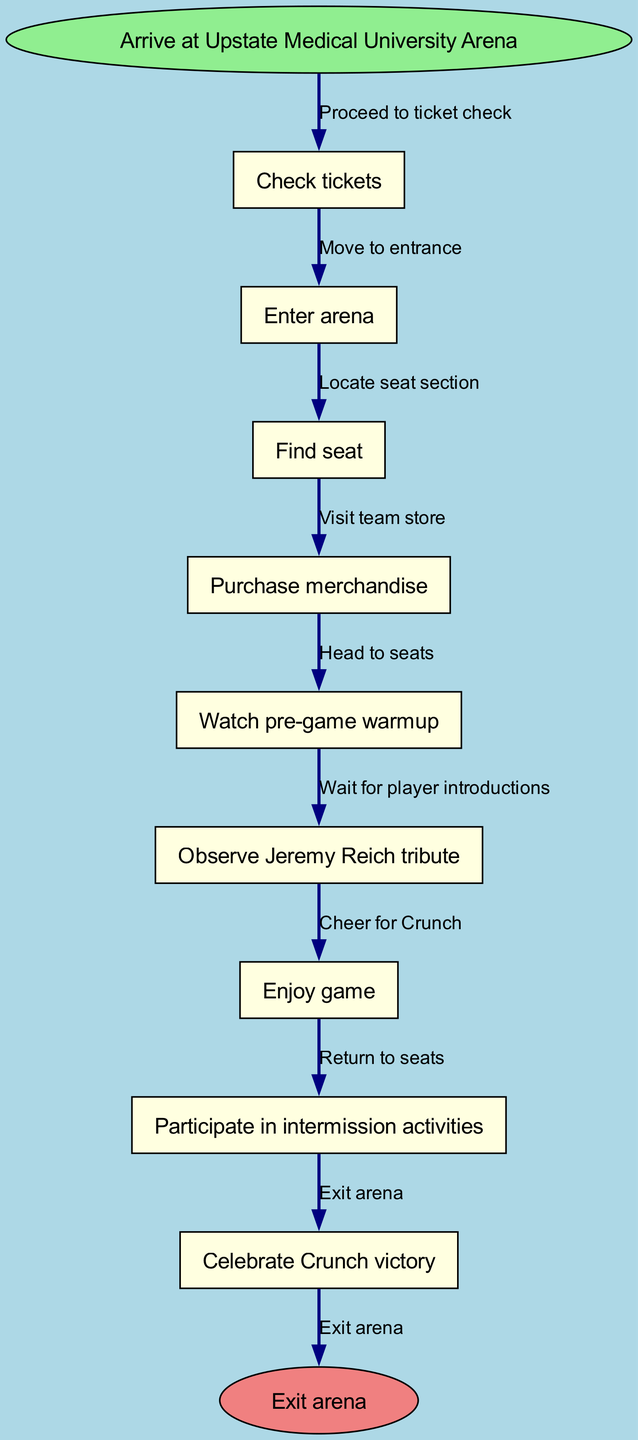What is the first action upon arriving at the arena? The flow chart starts with the first node being "Arrive at Upstate Medical University Arena." The next immediate action is shown in the edge corresponding to this node, which is "Check tickets."
Answer: Check tickets How many total nodes are there in the diagram? To find the total number of nodes, we count the main actions listed in the diagram: "Check tickets," "Enter arena," "Find seat," "Purchase merchandise," "Watch pre-game warmup," "Observe Jeremy Reich tribute," "Enjoy game," "Participate in intermission activities," and "Celebrate Crunch victory." There is also one start node and one end node, making a total of 10 nodes.
Answer: 10 What is the last action before exiting the arena? The last action in the flow diagram before reaching the end node "Exit arena" is represented by the node "Celebrate Crunch victory." The edge leading to "Exit arena" shows that this is the final action before leaving.
Answer: Celebrate Crunch victory Which activity is done immediately after observing the tribute? In the flow, the node "Observe Jeremy Reich tribute" is directly followed by the node "Enjoy game." This indicates that after observing the tribute, the next activity is to enjoy the game.
Answer: Enjoy game How many edges connect the nodes in the diagram? Each edge represents a connection between two nodes. Given there are 9 nodes leading to the end, we can deduce that there are 9 edges leading from one node to the next. This includes the final edge leading to the "Exit arena."
Answer: 9 What do you do after the merchandise purchase? The node "Purchase merchandise" is followed by the next action, which is "Watch pre-game warmup." Therefore, after purchasing merchandise, the next step is to watch the pre-game warmup.
Answer: Watch pre-game warmup Which action precedes finding your seat? In the diagram, the action "Enter arena" directly precedes "Find seat." This means that you must enter the arena before you can locate your seat.
Answer: Enter arena What is the purpose of the 'start' node in the diagram? The 'start' node, labeled "Arrive at Upstate Medical University Arena," indicates the entry point of the flow chart. It represents the first action that is taken when attending a Syracuse Crunch home game.
Answer: Arrive at Upstate Medical University Arena What is the final action before the game starts? Following the event "Watch pre-game warmup," which is close to the start of the game, the subsequent action shown in the flow chart is "Observe Jeremy Reich tribute." Therefore, this is the final activity before the game begins.
Answer: Observe Jeremy Reich tribute 